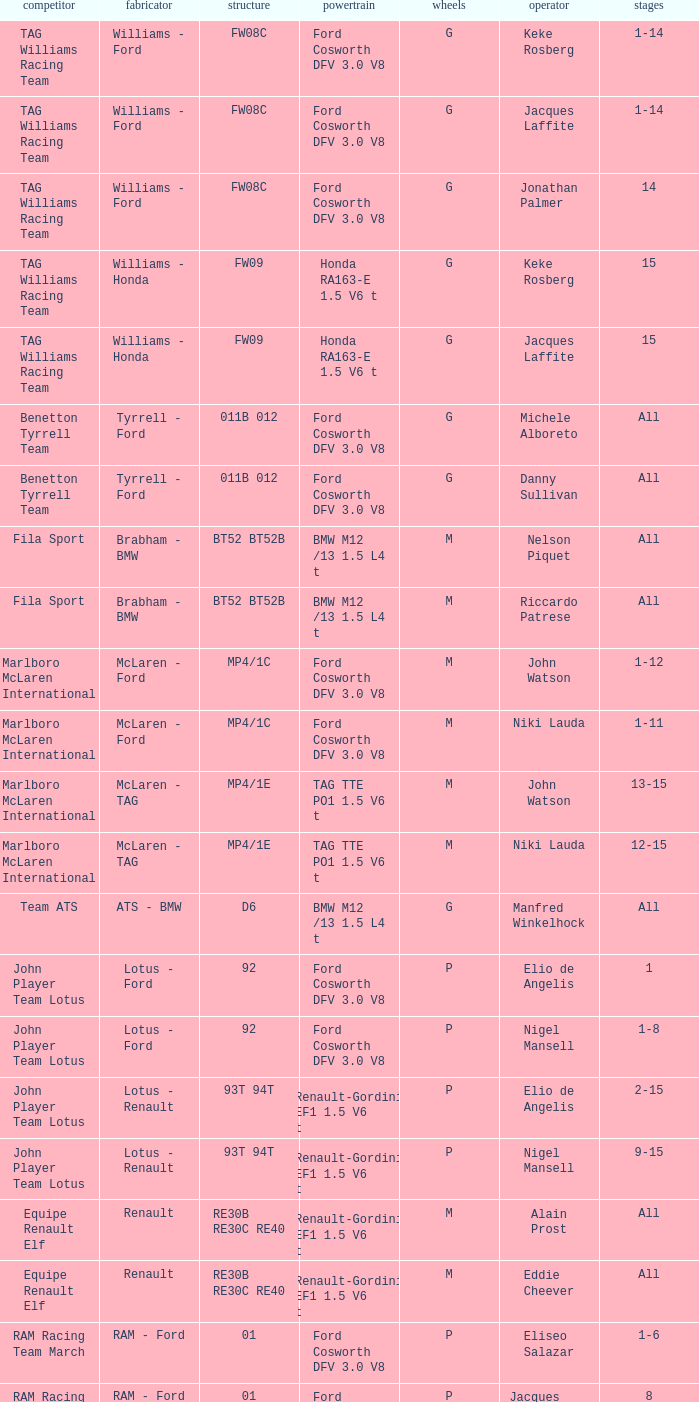Who is driver of the d6 chassis? Manfred Winkelhock. 